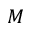<formula> <loc_0><loc_0><loc_500><loc_500>M</formula> 